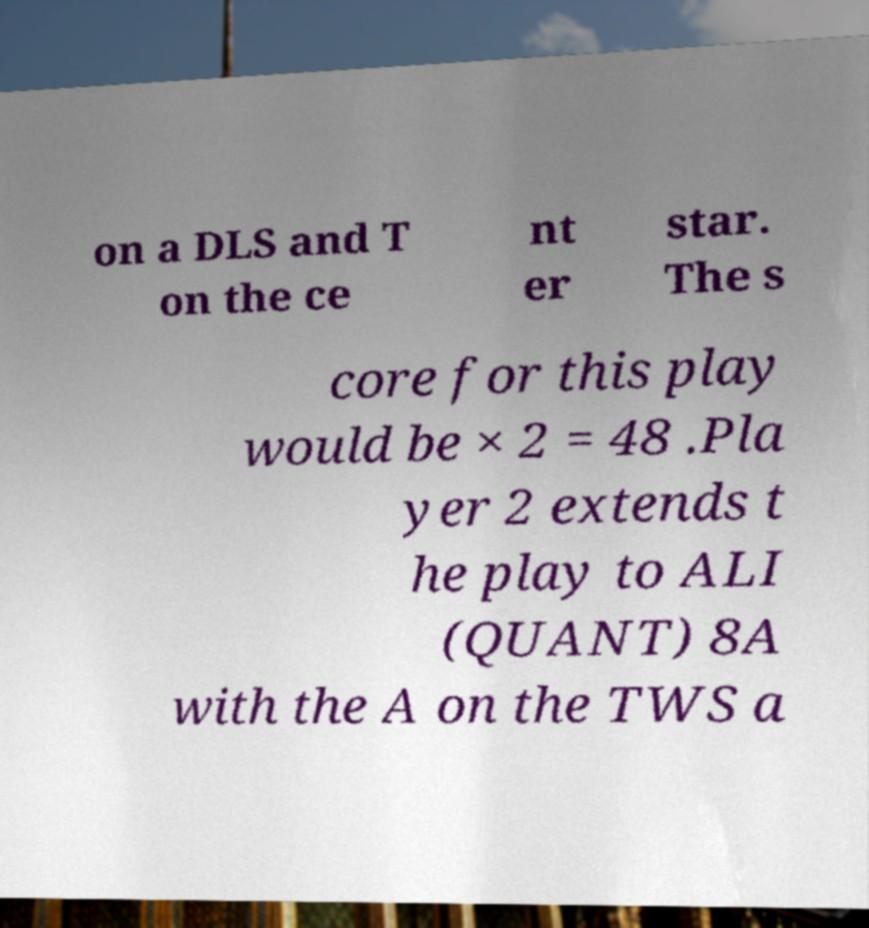There's text embedded in this image that I need extracted. Can you transcribe it verbatim? on a DLS and T on the ce nt er star. The s core for this play would be × 2 = 48 .Pla yer 2 extends t he play to ALI (QUANT) 8A with the A on the TWS a 